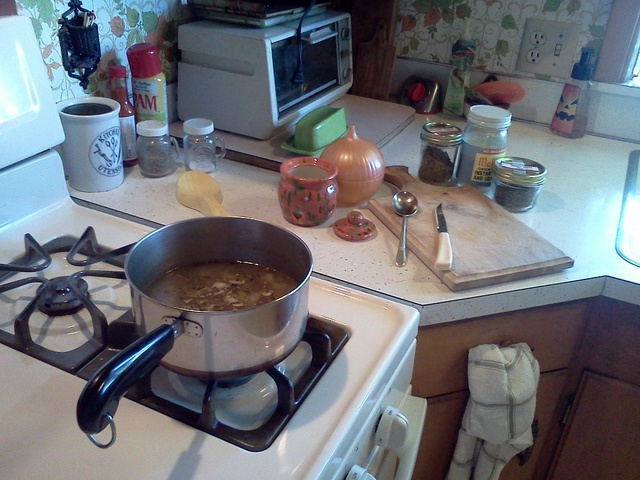Describe the objects in this image and their specific colors. I can see oven in purple, darkgray, black, gray, and lightgray tones, microwave in purple, gray, black, navy, and blue tones, bottle in purple, gray, and darkgray tones, bottle in purple, gray, darkgray, and black tones, and bottle in purple, gray, navy, and blue tones in this image. 